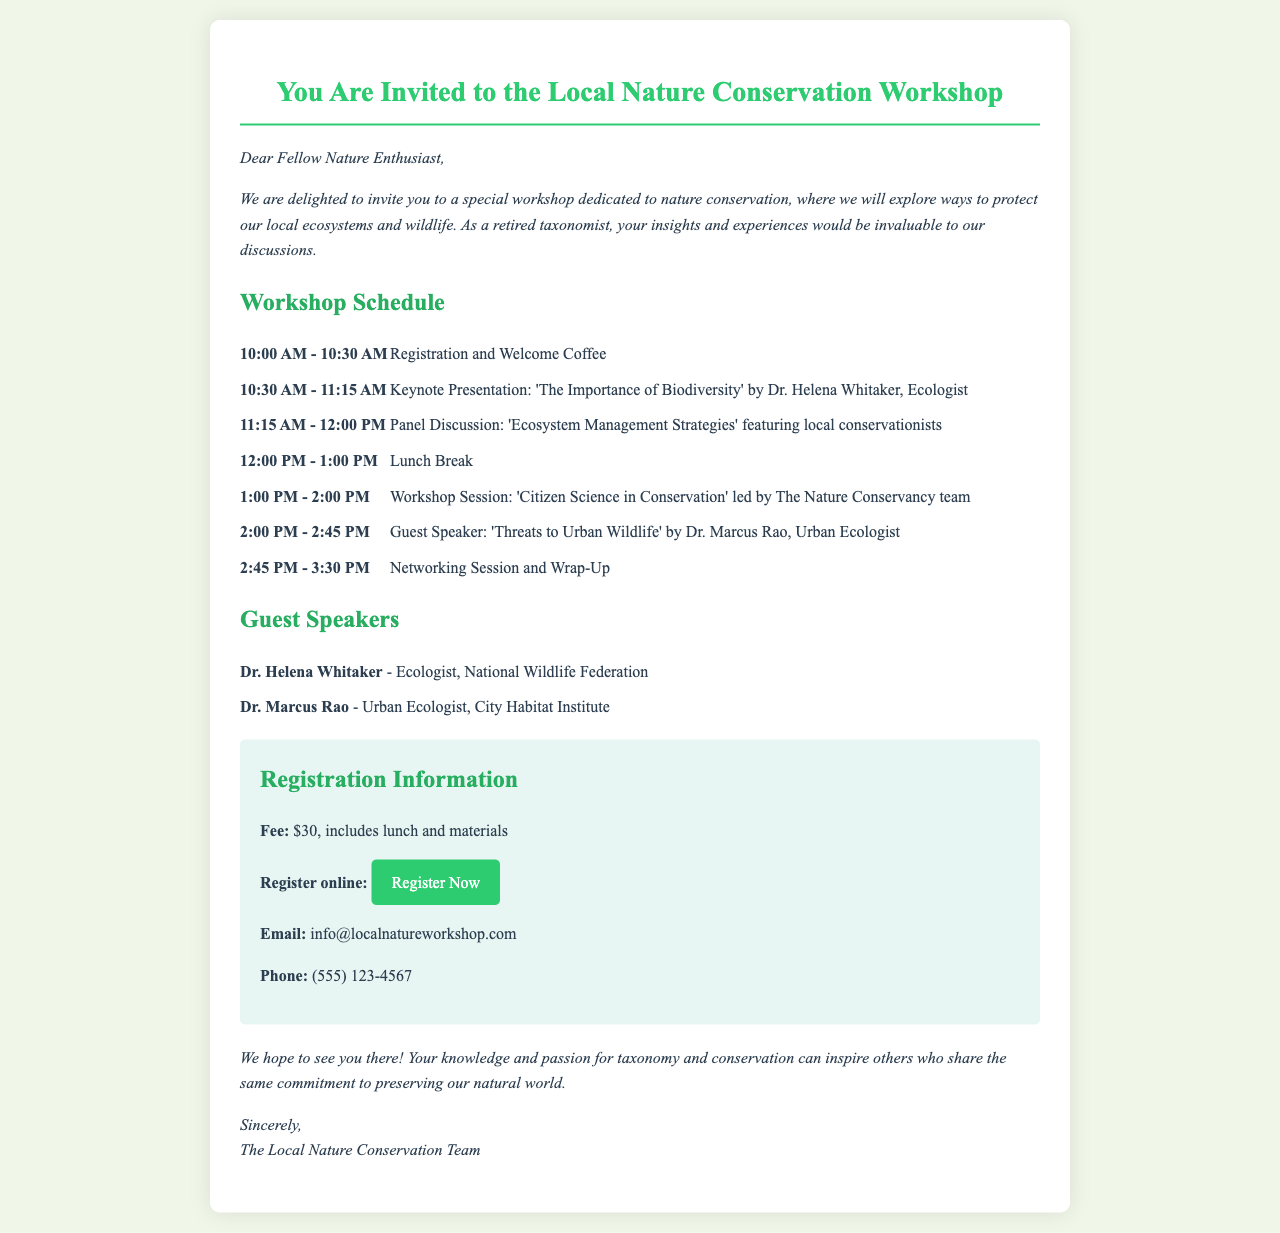What is the title of the workshop? The title can be found at the beginning of the document, which is "You Are Invited to the Local Nature Conservation Workshop."
Answer: You Are Invited to the Local Nature Conservation Workshop Who is the keynote speaker? The keynote speaker is listed in the schedule section, identified as "Dr. Helena Whitaker, Ecologist."
Answer: Dr. Helena Whitaker What time does the registration start? The registration time is specified in the schedule under the first event, which is "10:00 AM."
Answer: 10:00 AM What is the registration fee for the workshop? The registration fee is detailed in the registration information, which states that the fee is "$30."
Answer: $30 How long is the lunch break? The lunch break duration is mentioned in the schedule, and it lasts for "1 hour."
Answer: 1 hour Which organization does Dr. Marcus Rao represent? Dr. Marcus Rao's affiliation is given in the guest speaker section, indicating he works for the "City Habitat Institute."
Answer: City Habitat Institute What is the website for registration? The registration link is provided in the registration information as "https://www.localnatureworkshop.com/register."
Answer: https://www.localnatureworkshop.com/register What type of session follows the lunch break? The schedule indicates that after the lunch break, there is a "Workshop Session."
Answer: Workshop Session What is the purpose of the workshop? The introduction section provides insight, stating it is dedicated to "nature conservation."
Answer: nature conservation 